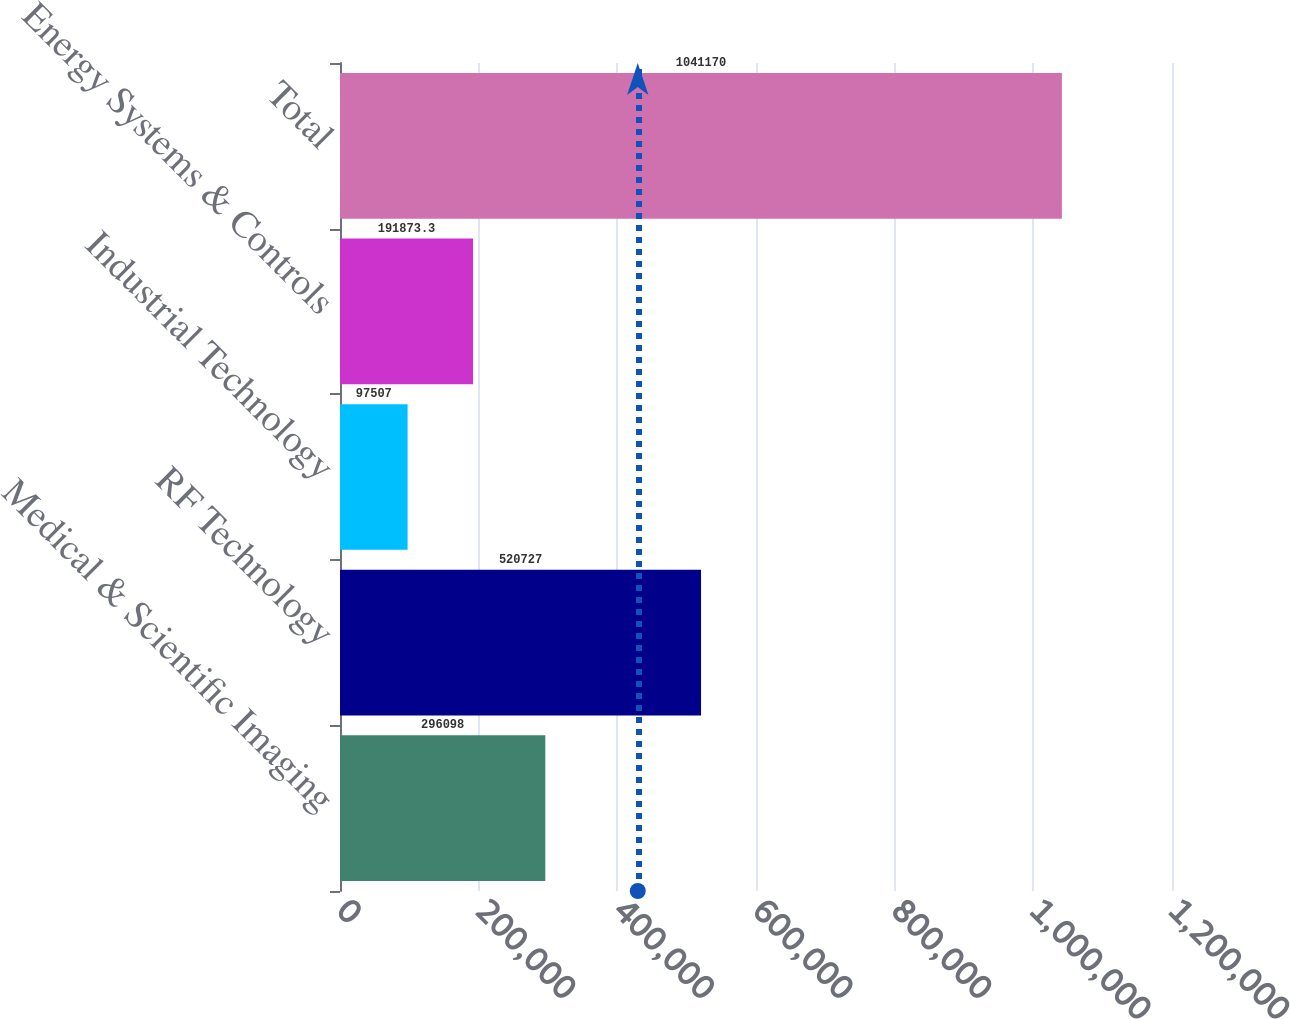Convert chart. <chart><loc_0><loc_0><loc_500><loc_500><bar_chart><fcel>Medical & Scientific Imaging<fcel>RF Technology<fcel>Industrial Technology<fcel>Energy Systems & Controls<fcel>Total<nl><fcel>296098<fcel>520727<fcel>97507<fcel>191873<fcel>1.04117e+06<nl></chart> 